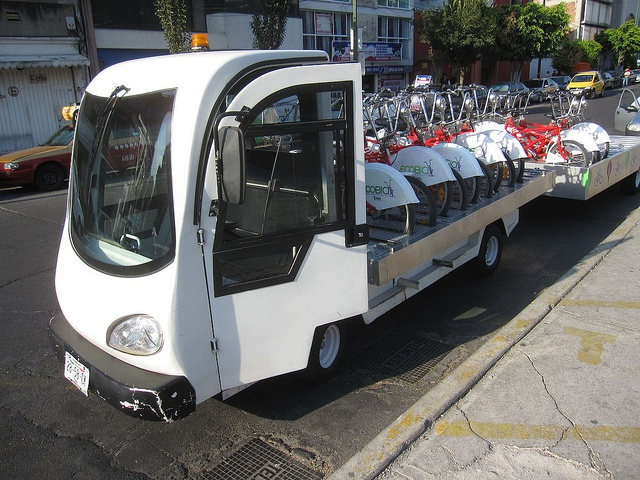Describe the objects in this image and their specific colors. I can see truck in black, lightgray, gray, and darkgray tones, car in black and gray tones, bicycle in black, gray, and darkgray tones, bicycle in black and gray tones, and bicycle in black, white, gray, darkgray, and salmon tones in this image. 